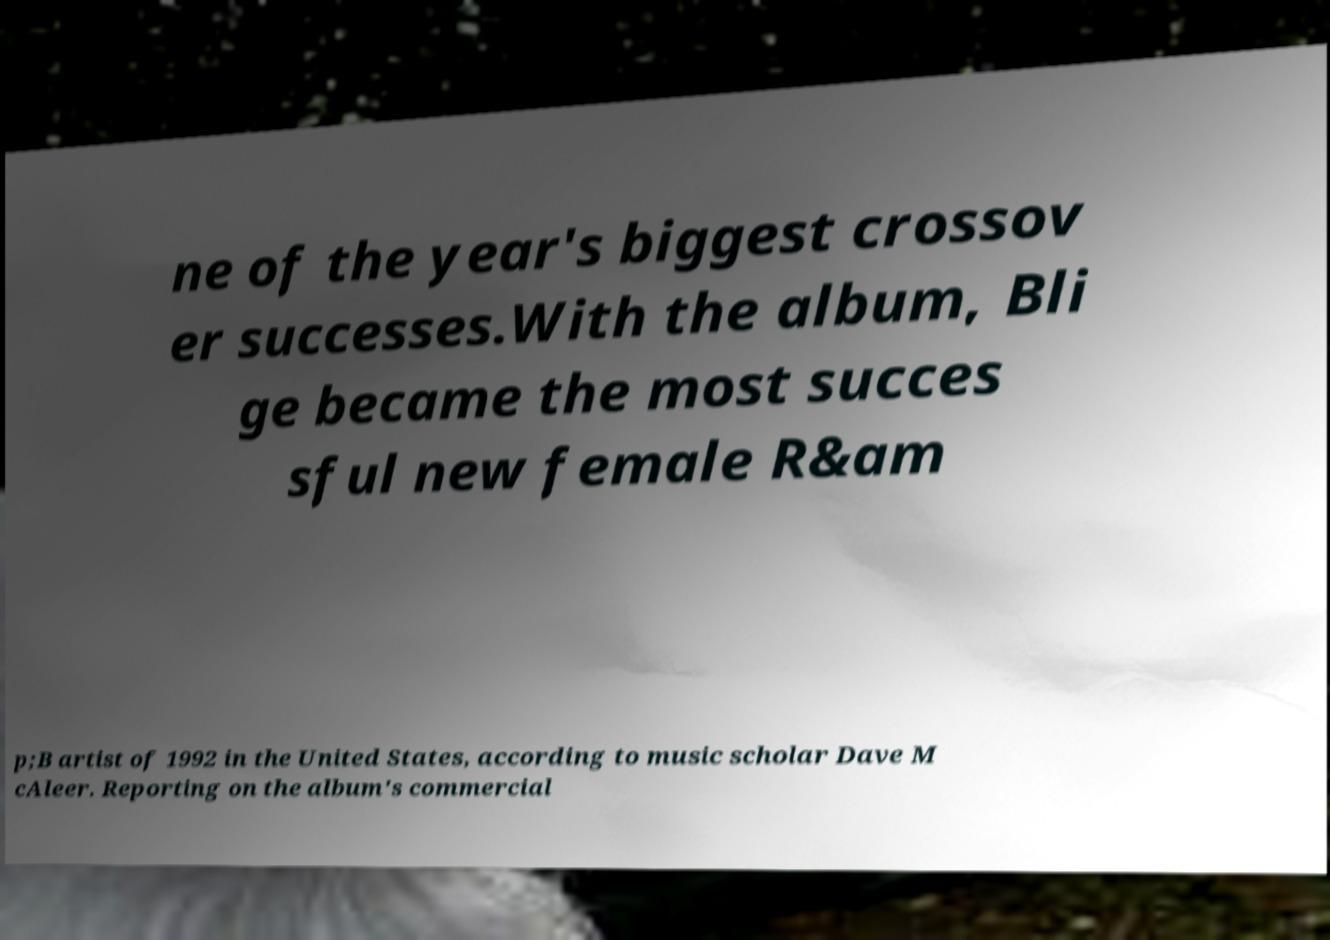I need the written content from this picture converted into text. Can you do that? ne of the year's biggest crossov er successes.With the album, Bli ge became the most succes sful new female R&am p;B artist of 1992 in the United States, according to music scholar Dave M cAleer. Reporting on the album's commercial 